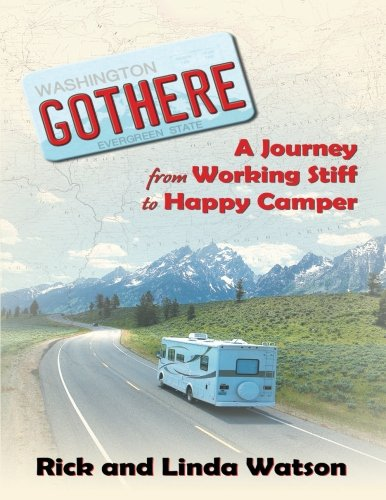Describe the mood or tone suggested by the book's cover design. The mood suggested by the book's cover is one of freedom and relaxation, underscored by the imagery of an open road and a broad landscape, aiming to evoke feelings of escape from daily routines to embrace adventure and peace in nature. 